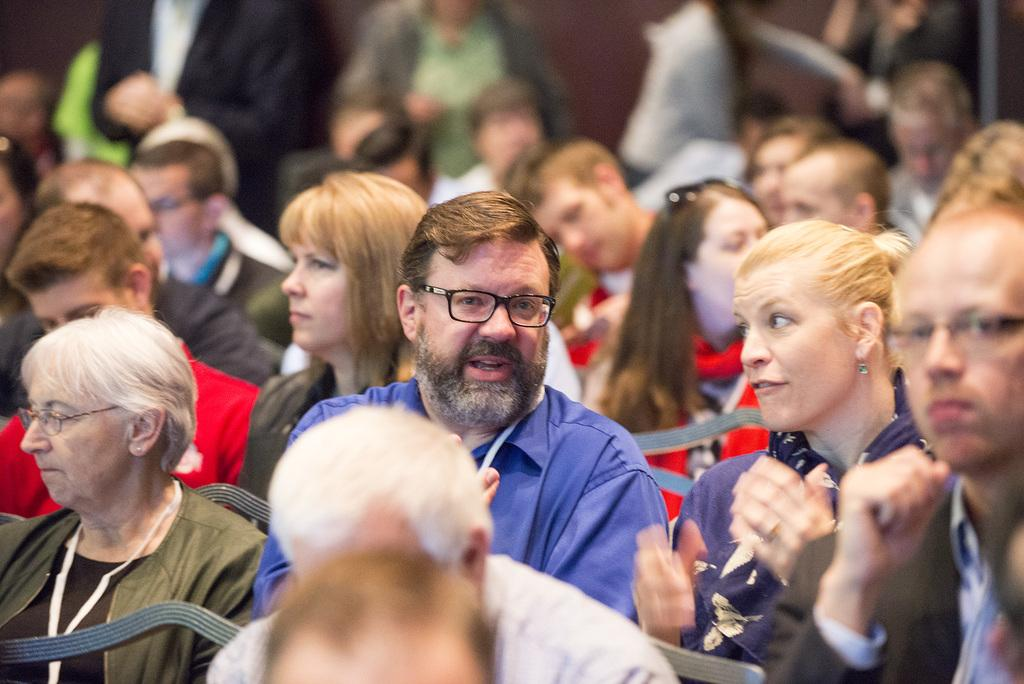What are the people in the image doing? The people in the image are sitting on chairs. Are there any other people visible in the image? Yes, there are people standing behind the sitting people. What can be seen in the background of the image? There is a wall in the background of the image. What type of train is visible in the image? There is no train present in the image. How many coils of hair can be seen on the people in the image? The image does not show any hair, so it is not possible to determine the number of coils. 